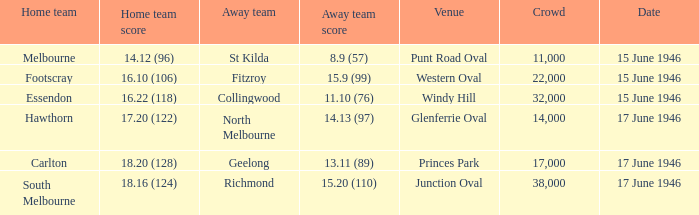On what date was a game played at Windy Hill? 15 June 1946. 